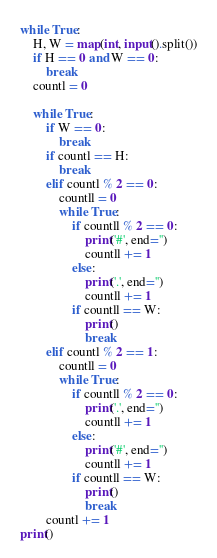<code> <loc_0><loc_0><loc_500><loc_500><_Python_>while True:
	H, W = map(int, input().split())
	if H == 0 and W == 0:
		break	
	countl = 0
	
	while True:
		if W == 0:
			break
		if countl == H:
			break
		elif countl % 2 == 0:
			countll = 0
			while True:
				if countll % 2 == 0:
					print('#', end='')
					countll += 1
				else:
					print('.', end='')
					countll += 1
				if countll == W:
					print()
					break
		elif countl % 2 == 1:
			countll = 0
			while True:
				if countll % 2 == 0:
					print('.', end='')
					countll += 1
				else:
					print('#', end='')
					countll += 1
				if countll == W:
					print()
					break
		countl += 1
print() </code> 